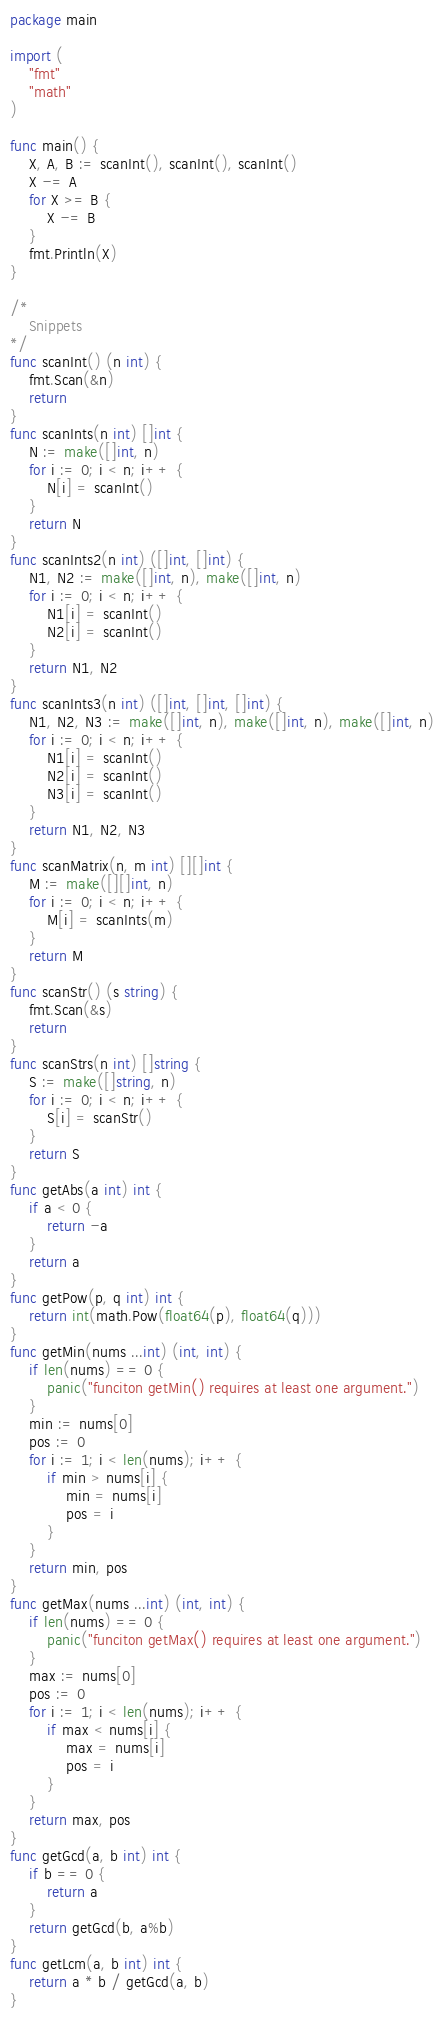Convert code to text. <code><loc_0><loc_0><loc_500><loc_500><_Go_>package main

import (
	"fmt"
	"math"
)

func main() {
	X, A, B := scanInt(), scanInt(), scanInt()
	X -= A
	for X >= B {
		X -= B
	}
	fmt.Println(X)
}

/*
	Snippets
*/
func scanInt() (n int) {
	fmt.Scan(&n)
	return
}
func scanInts(n int) []int {
	N := make([]int, n)
	for i := 0; i < n; i++ {
		N[i] = scanInt()
	}
	return N
}
func scanInts2(n int) ([]int, []int) {
	N1, N2 := make([]int, n), make([]int, n)
	for i := 0; i < n; i++ {
		N1[i] = scanInt()
		N2[i] = scanInt()
	}
	return N1, N2
}
func scanInts3(n int) ([]int, []int, []int) {
	N1, N2, N3 := make([]int, n), make([]int, n), make([]int, n)
	for i := 0; i < n; i++ {
		N1[i] = scanInt()
		N2[i] = scanInt()
		N3[i] = scanInt()
	}
	return N1, N2, N3
}
func scanMatrix(n, m int) [][]int {
	M := make([][]int, n)
	for i := 0; i < n; i++ {
		M[i] = scanInts(m)
	}
	return M
}
func scanStr() (s string) {
	fmt.Scan(&s)
	return
}
func scanStrs(n int) []string {
	S := make([]string, n)
	for i := 0; i < n; i++ {
		S[i] = scanStr()
	}
	return S
}
func getAbs(a int) int {
	if a < 0 {
		return -a
	}
	return a
}
func getPow(p, q int) int {
	return int(math.Pow(float64(p), float64(q)))
}
func getMin(nums ...int) (int, int) {
	if len(nums) == 0 {
		panic("funciton getMin() requires at least one argument.")
	}
	min := nums[0]
	pos := 0
	for i := 1; i < len(nums); i++ {
		if min > nums[i] {
			min = nums[i]
			pos = i
		}
	}
	return min, pos
}
func getMax(nums ...int) (int, int) {
	if len(nums) == 0 {
		panic("funciton getMax() requires at least one argument.")
	}
	max := nums[0]
	pos := 0
	for i := 1; i < len(nums); i++ {
		if max < nums[i] {
			max = nums[i]
			pos = i
		}
	}
	return max, pos
}
func getGcd(a, b int) int {
	if b == 0 {
		return a
	}
	return getGcd(b, a%b)
}
func getLcm(a, b int) int {
	return a * b / getGcd(a, b)
}
</code> 